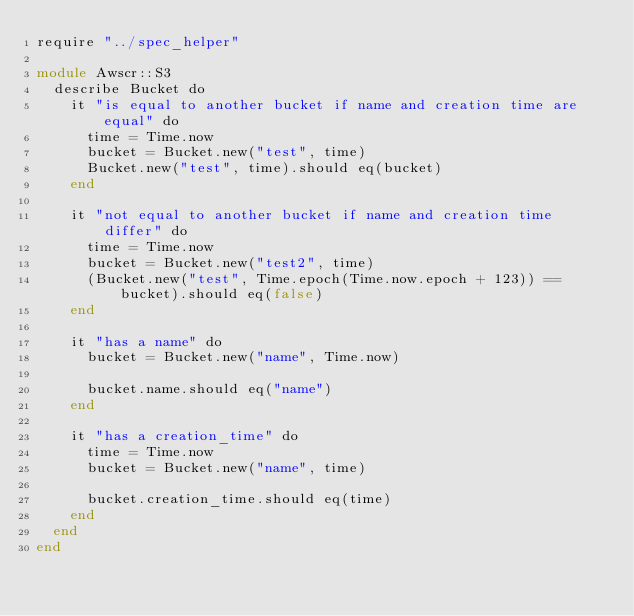<code> <loc_0><loc_0><loc_500><loc_500><_Crystal_>require "../spec_helper"

module Awscr::S3
  describe Bucket do
    it "is equal to another bucket if name and creation time are equal" do
      time = Time.now
      bucket = Bucket.new("test", time)
      Bucket.new("test", time).should eq(bucket)
    end

    it "not equal to another bucket if name and creation time differ" do
      time = Time.now
      bucket = Bucket.new("test2", time)
      (Bucket.new("test", Time.epoch(Time.now.epoch + 123)) == bucket).should eq(false)
    end

    it "has a name" do
      bucket = Bucket.new("name", Time.now)

      bucket.name.should eq("name")
    end

    it "has a creation_time" do
      time = Time.now
      bucket = Bucket.new("name", time)

      bucket.creation_time.should eq(time)
    end
  end
end
</code> 